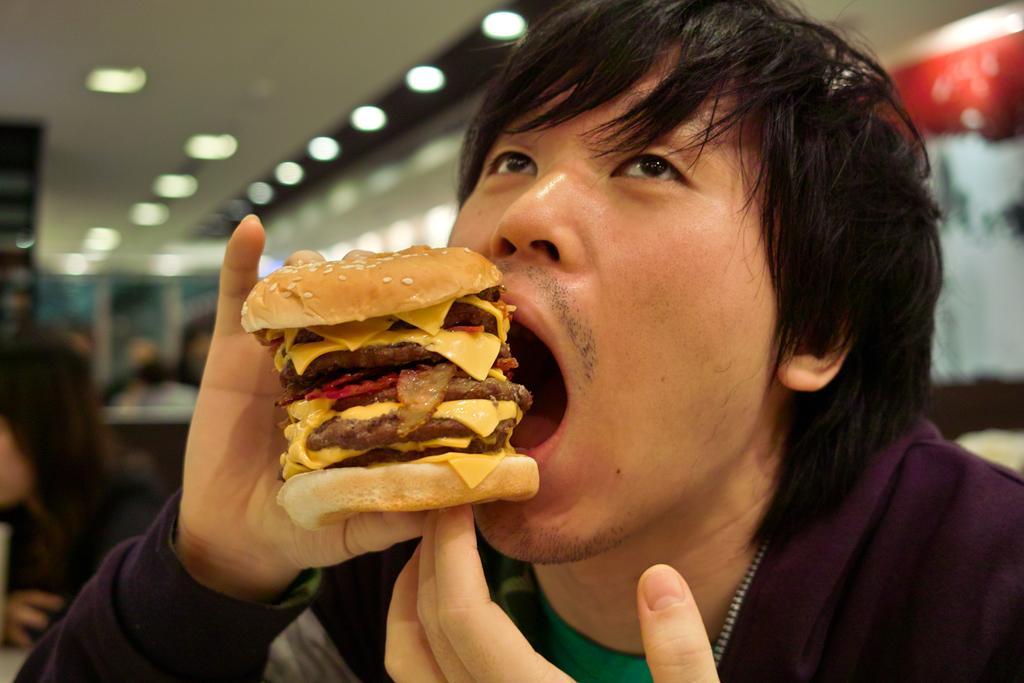How would you summarize this image in a sentence or two? In this image we can see few people. A person is eating some food in the image. There is an object at the right side of the image. There are many lights attached to the roof in the image. 